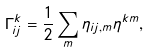<formula> <loc_0><loc_0><loc_500><loc_500>\Gamma ^ { k } _ { i j } = \frac { 1 } { 2 } \sum _ { m } \eta _ { i j , m } \eta ^ { k m } ,</formula> 